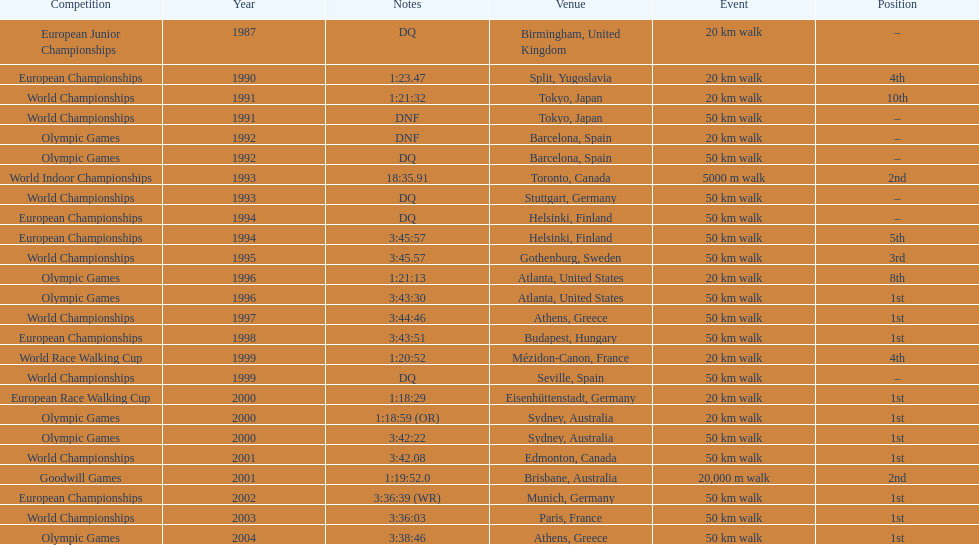In what year was korzeniowski's last competition? 2004. 